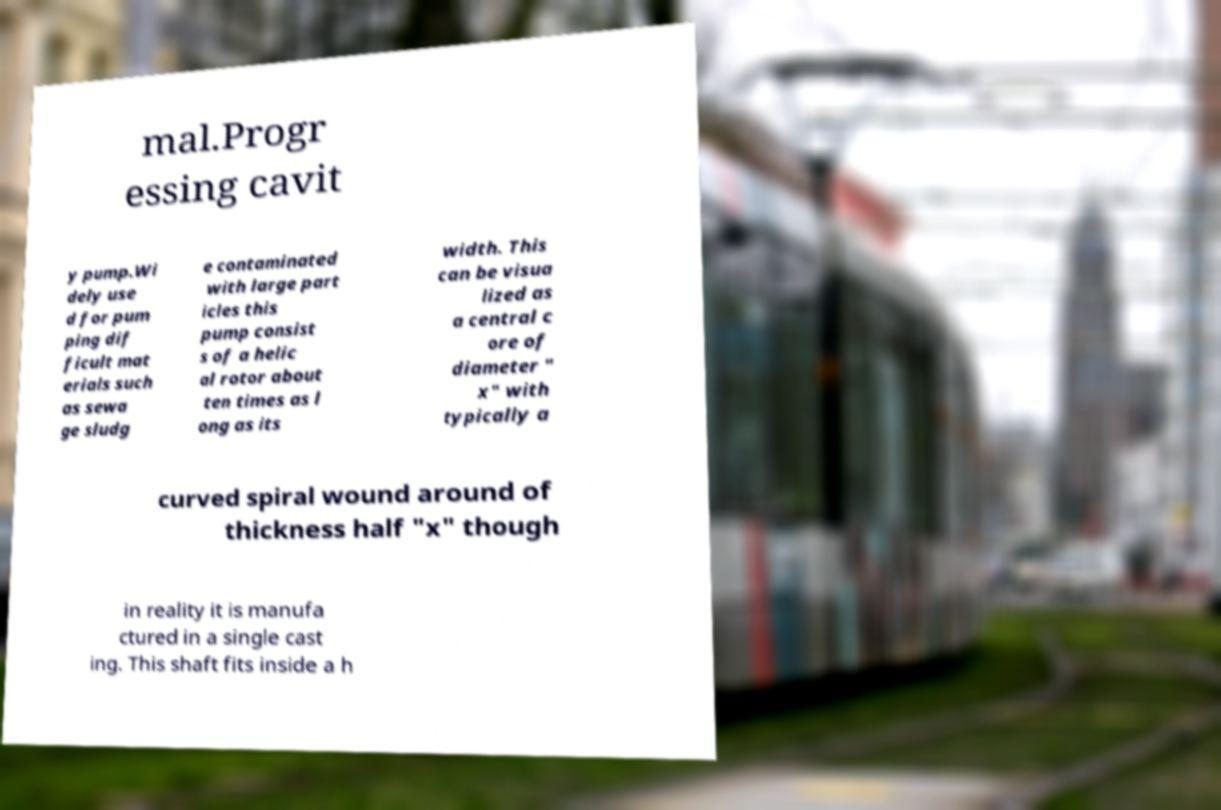Please identify and transcribe the text found in this image. mal.Progr essing cavit y pump.Wi dely use d for pum ping dif ficult mat erials such as sewa ge sludg e contaminated with large part icles this pump consist s of a helic al rotor about ten times as l ong as its width. This can be visua lized as a central c ore of diameter " x" with typically a curved spiral wound around of thickness half "x" though in reality it is manufa ctured in a single cast ing. This shaft fits inside a h 